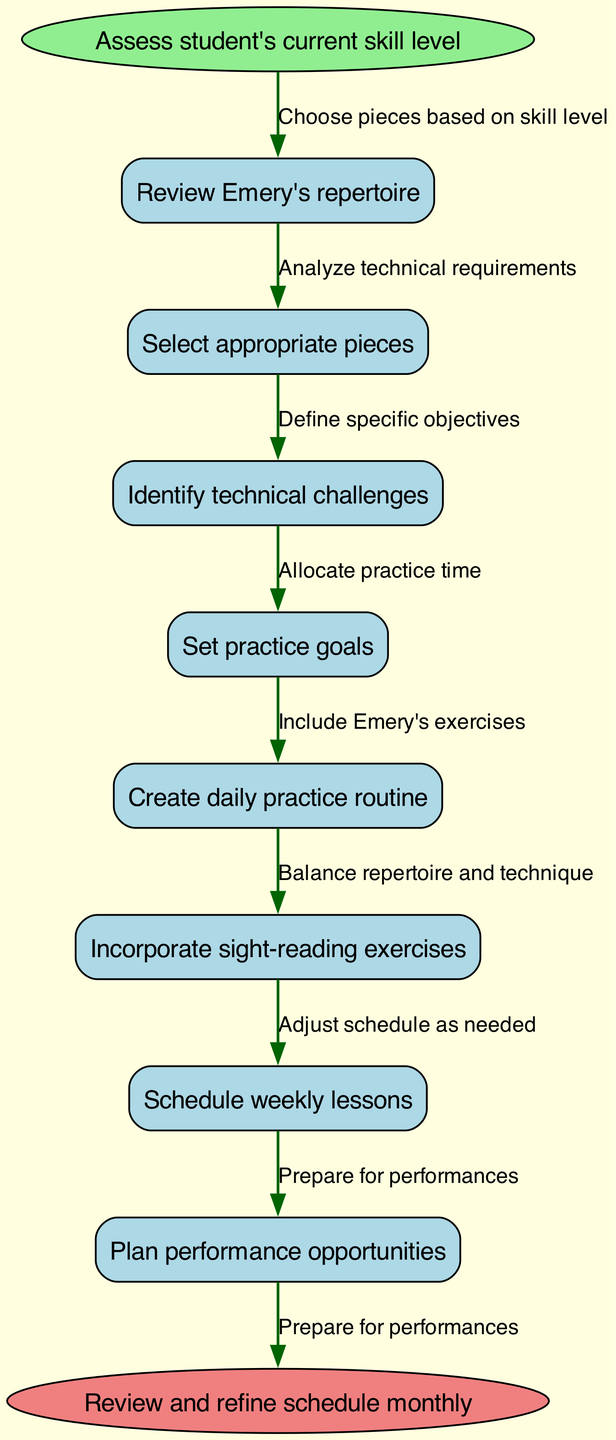What's the starting point of the workflow? The starting point of the workflow is indicated by the 'start' node, which is "Assess student's current skill level."
Answer: Assess student's current skill level How many nodes are in the diagram? By counting the elements listed in the 'nodes' section of the data, there are a total of 8 nodes (1 start, 6 intermediate, and 1 end).
Answer: 8 What is the last step before the end of the workflow? The last step is linked to the end node. By following the edges, the last node before the 'end' node is "Plan performance opportunities."
Answer: Plan performance opportunities Which node focuses on setting practice objectives? The node that focuses on setting practice objectives is labeled "Set practice goals." This node is part of the flow of creating a customized practice schedule.
Answer: Set practice goals What are the edges used to connect "Select appropriate pieces" to the next node? The edge that connects "Select appropriate pieces" is labeled "Choose pieces based on skill level," leading to "Identify technical challenges."
Answer: Choose pieces based on skill level How do the nodes related to practice incorporate Emery's exercises? The node "Incorporate sight-reading exercises" directly includes practices associated with Emery's technique, thus aiding in skill development.
Answer: Include Emery's exercises What is the primary function of the "Create daily practice routine" node? The primary function of "Create daily practice routine" is to allocate practice time, which is essential for student progress and scheduling.
Answer: Allocate practice time What is the final output of the workflow? The final output is represented by the 'end' node, which indicates that the process concludes with "Review and refine schedule monthly."
Answer: Review and refine schedule monthly 